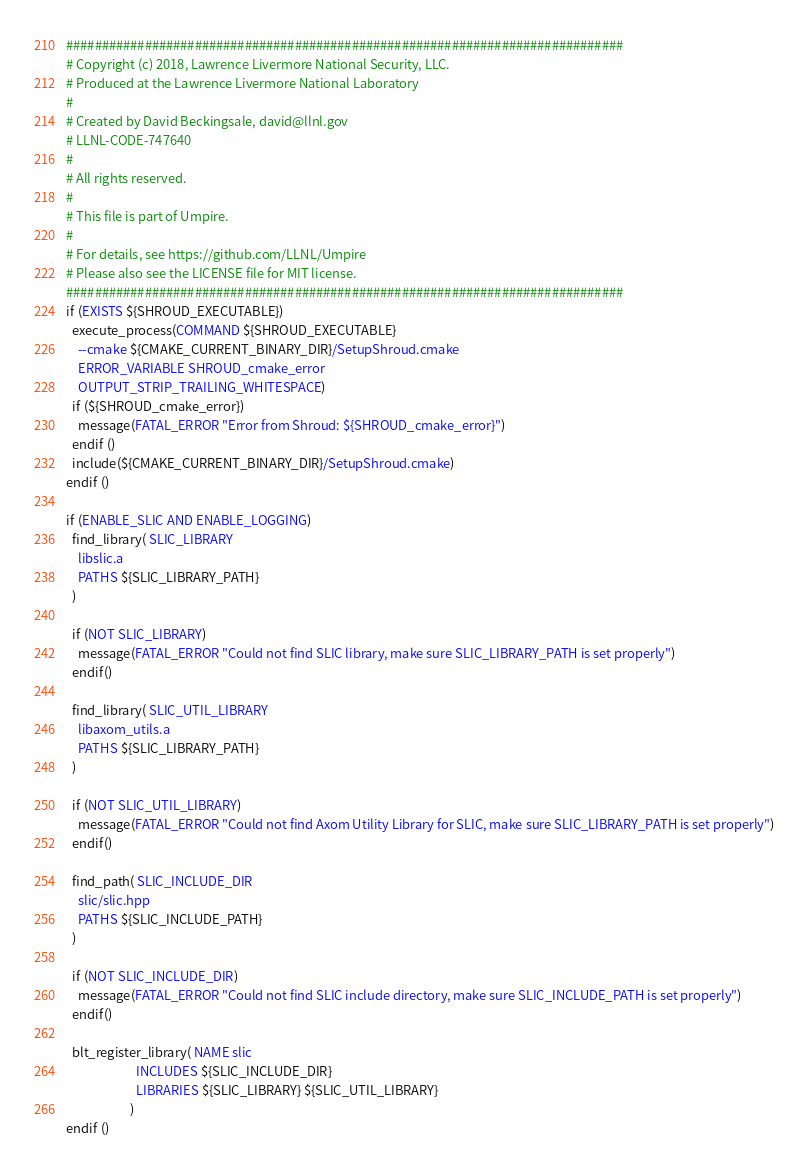<code> <loc_0><loc_0><loc_500><loc_500><_CMake_>##############################################################################
# Copyright (c) 2018, Lawrence Livermore National Security, LLC.
# Produced at the Lawrence Livermore National Laboratory
#
# Created by David Beckingsale, david@llnl.gov
# LLNL-CODE-747640
#
# All rights reserved.
#
# This file is part of Umpire.
#
# For details, see https://github.com/LLNL/Umpire
# Please also see the LICENSE file for MIT license.
##############################################################################
if (EXISTS ${SHROUD_EXECUTABLE})
  execute_process(COMMAND ${SHROUD_EXECUTABLE}
    --cmake ${CMAKE_CURRENT_BINARY_DIR}/SetupShroud.cmake
    ERROR_VARIABLE SHROUD_cmake_error
    OUTPUT_STRIP_TRAILING_WHITESPACE)
  if (${SHROUD_cmake_error})
    message(FATAL_ERROR "Error from Shroud: ${SHROUD_cmake_error}")
  endif ()
  include(${CMAKE_CURRENT_BINARY_DIR}/SetupShroud.cmake)
endif ()

if (ENABLE_SLIC AND ENABLE_LOGGING)
  find_library( SLIC_LIBRARY
    libslic.a
    PATHS ${SLIC_LIBRARY_PATH} 
  )

  if (NOT SLIC_LIBRARY)
    message(FATAL_ERROR "Could not find SLIC library, make sure SLIC_LIBRARY_PATH is set properly")
  endif()

  find_library( SLIC_UTIL_LIBRARY
    libaxom_utils.a
    PATHS ${SLIC_LIBRARY_PATH} 
  )

  if (NOT SLIC_UTIL_LIBRARY)
    message(FATAL_ERROR "Could not find Axom Utility Library for SLIC, make sure SLIC_LIBRARY_PATH is set properly")
  endif()

  find_path( SLIC_INCLUDE_DIR
    slic/slic.hpp
    PATHS ${SLIC_INCLUDE_PATH}
  )

  if (NOT SLIC_INCLUDE_DIR)
    message(FATAL_ERROR "Could not find SLIC include directory, make sure SLIC_INCLUDE_PATH is set properly")
  endif()

  blt_register_library( NAME slic
                        INCLUDES ${SLIC_INCLUDE_DIR}
                        LIBRARIES ${SLIC_LIBRARY} ${SLIC_UTIL_LIBRARY}
                      )
endif ()
</code> 